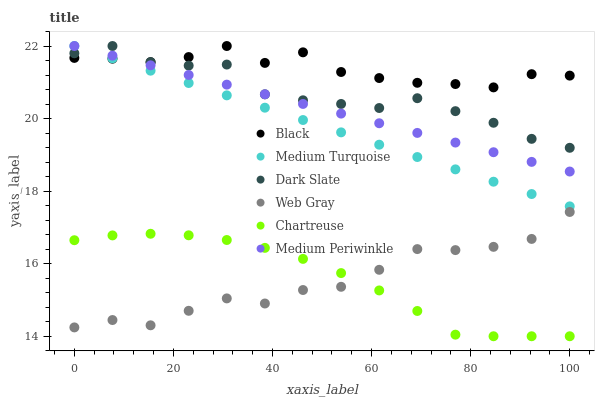Does Web Gray have the minimum area under the curve?
Answer yes or no. Yes. Does Black have the maximum area under the curve?
Answer yes or no. Yes. Does Medium Periwinkle have the minimum area under the curve?
Answer yes or no. No. Does Medium Periwinkle have the maximum area under the curve?
Answer yes or no. No. Is Medium Turquoise the smoothest?
Answer yes or no. Yes. Is Black the roughest?
Answer yes or no. Yes. Is Medium Periwinkle the smoothest?
Answer yes or no. No. Is Medium Periwinkle the roughest?
Answer yes or no. No. Does Chartreuse have the lowest value?
Answer yes or no. Yes. Does Medium Periwinkle have the lowest value?
Answer yes or no. No. Does Medium Turquoise have the highest value?
Answer yes or no. Yes. Does Chartreuse have the highest value?
Answer yes or no. No. Is Web Gray less than Medium Periwinkle?
Answer yes or no. Yes. Is Black greater than Web Gray?
Answer yes or no. Yes. Does Medium Periwinkle intersect Dark Slate?
Answer yes or no. Yes. Is Medium Periwinkle less than Dark Slate?
Answer yes or no. No. Is Medium Periwinkle greater than Dark Slate?
Answer yes or no. No. Does Web Gray intersect Medium Periwinkle?
Answer yes or no. No. 